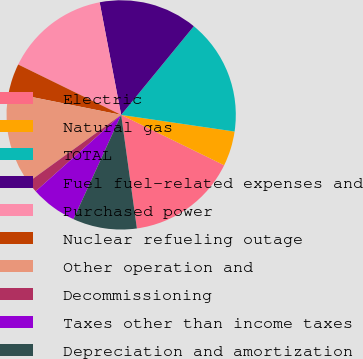<chart> <loc_0><loc_0><loc_500><loc_500><pie_chart><fcel>Electric<fcel>Natural gas<fcel>TOTAL<fcel>Fuel fuel-related expenses and<fcel>Purchased power<fcel>Nuclear refueling outage<fcel>Other operation and<fcel>Decommissioning<fcel>Taxes other than income taxes<fcel>Depreciation and amortization<nl><fcel>15.57%<fcel>4.92%<fcel>16.39%<fcel>13.93%<fcel>14.75%<fcel>4.1%<fcel>13.11%<fcel>1.64%<fcel>6.56%<fcel>9.02%<nl></chart> 